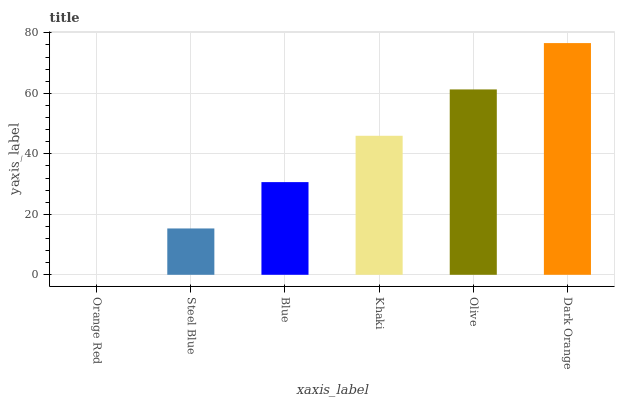Is Steel Blue the minimum?
Answer yes or no. No. Is Steel Blue the maximum?
Answer yes or no. No. Is Steel Blue greater than Orange Red?
Answer yes or no. Yes. Is Orange Red less than Steel Blue?
Answer yes or no. Yes. Is Orange Red greater than Steel Blue?
Answer yes or no. No. Is Steel Blue less than Orange Red?
Answer yes or no. No. Is Khaki the high median?
Answer yes or no. Yes. Is Blue the low median?
Answer yes or no. Yes. Is Dark Orange the high median?
Answer yes or no. No. Is Steel Blue the low median?
Answer yes or no. No. 